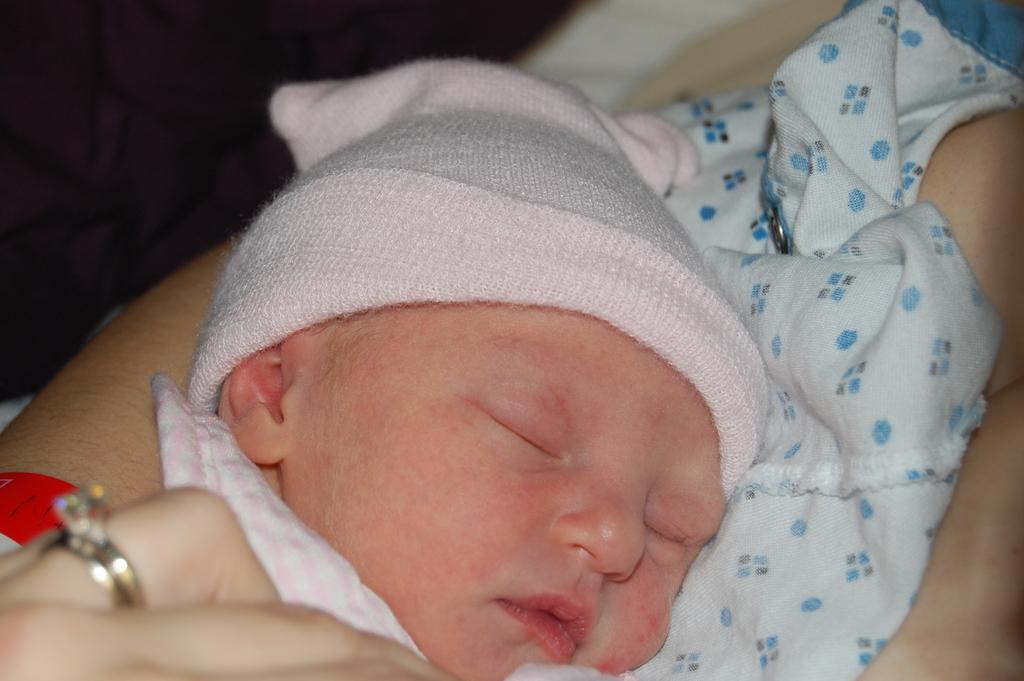What is the main subject of the image? There is a baby in the image. What is the baby's position in the image? The baby is laying over a place. What is the baby wearing on their head? The baby is wearing a cap. Can you identify any accessories worn by someone in the image? There is a ring present on the finger of a person in the image. What type of orange is being used as a toy by the baby in the image? There is no orange present in the image; the baby is wearing a cap. Can you describe the baby's journey in the image? The image does not depict a journey; it shows the baby laying over a place. 